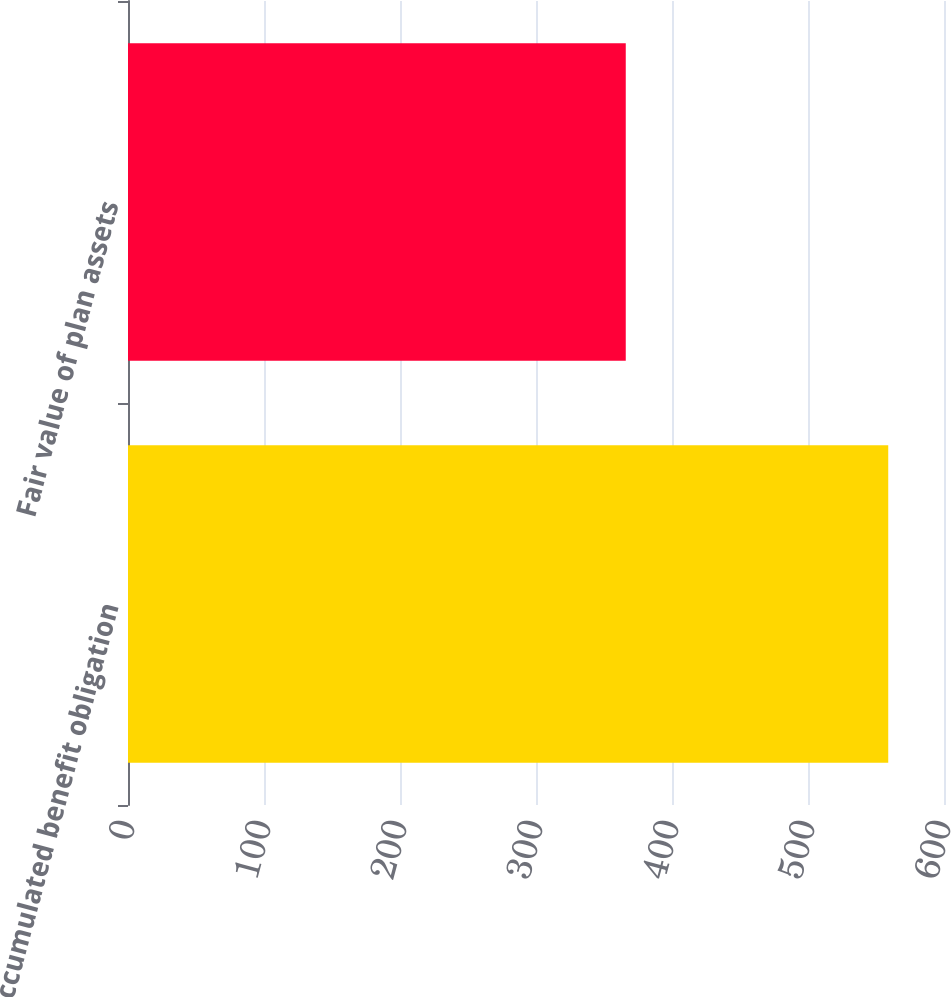Convert chart. <chart><loc_0><loc_0><loc_500><loc_500><bar_chart><fcel>Accumulated benefit obligation<fcel>Fair value of plan assets<nl><fcel>559<fcel>366<nl></chart> 